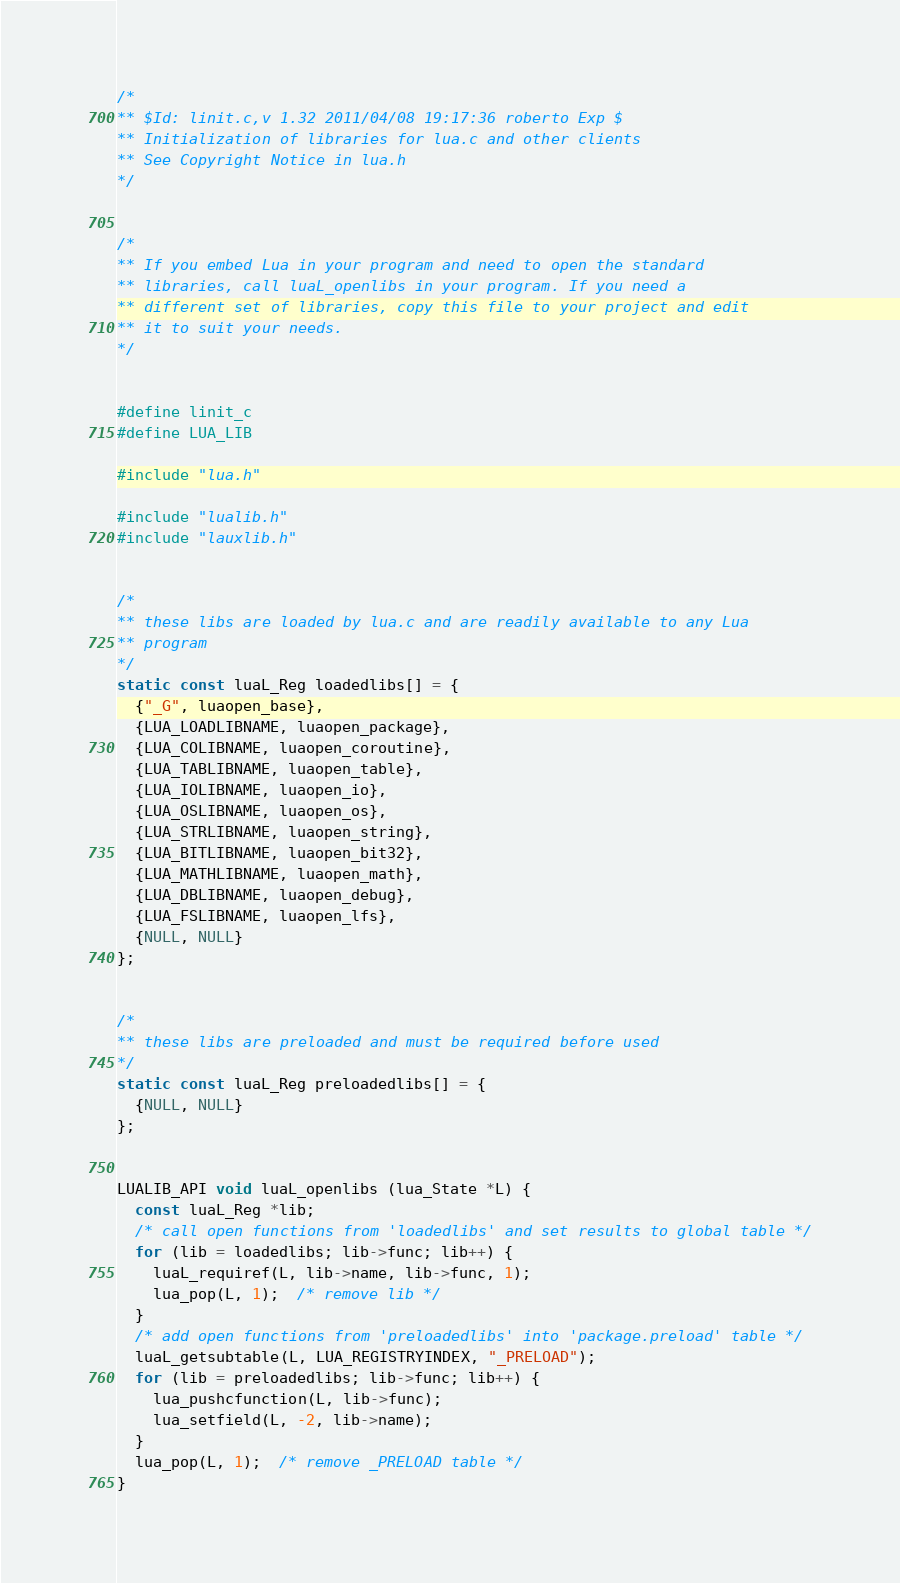Convert code to text. <code><loc_0><loc_0><loc_500><loc_500><_C_>/*
** $Id: linit.c,v 1.32 2011/04/08 19:17:36 roberto Exp $
** Initialization of libraries for lua.c and other clients
** See Copyright Notice in lua.h
*/


/*
** If you embed Lua in your program and need to open the standard
** libraries, call luaL_openlibs in your program. If you need a
** different set of libraries, copy this file to your project and edit
** it to suit your needs.
*/


#define linit_c
#define LUA_LIB

#include "lua.h"

#include "lualib.h"
#include "lauxlib.h"


/*
** these libs are loaded by lua.c and are readily available to any Lua
** program
*/
static const luaL_Reg loadedlibs[] = {
  {"_G", luaopen_base},
  {LUA_LOADLIBNAME, luaopen_package},
  {LUA_COLIBNAME, luaopen_coroutine},
  {LUA_TABLIBNAME, luaopen_table},
  {LUA_IOLIBNAME, luaopen_io},
  {LUA_OSLIBNAME, luaopen_os},
  {LUA_STRLIBNAME, luaopen_string},
  {LUA_BITLIBNAME, luaopen_bit32},
  {LUA_MATHLIBNAME, luaopen_math},
  {LUA_DBLIBNAME, luaopen_debug},
  {LUA_FSLIBNAME, luaopen_lfs},
  {NULL, NULL}
};


/*
** these libs are preloaded and must be required before used
*/
static const luaL_Reg preloadedlibs[] = {
  {NULL, NULL}
};


LUALIB_API void luaL_openlibs (lua_State *L) {
  const luaL_Reg *lib;
  /* call open functions from 'loadedlibs' and set results to global table */
  for (lib = loadedlibs; lib->func; lib++) {
    luaL_requiref(L, lib->name, lib->func, 1);
    lua_pop(L, 1);  /* remove lib */
  }
  /* add open functions from 'preloadedlibs' into 'package.preload' table */
  luaL_getsubtable(L, LUA_REGISTRYINDEX, "_PRELOAD");
  for (lib = preloadedlibs; lib->func; lib++) {
    lua_pushcfunction(L, lib->func);
    lua_setfield(L, -2, lib->name);
  }
  lua_pop(L, 1);  /* remove _PRELOAD table */
}

</code> 